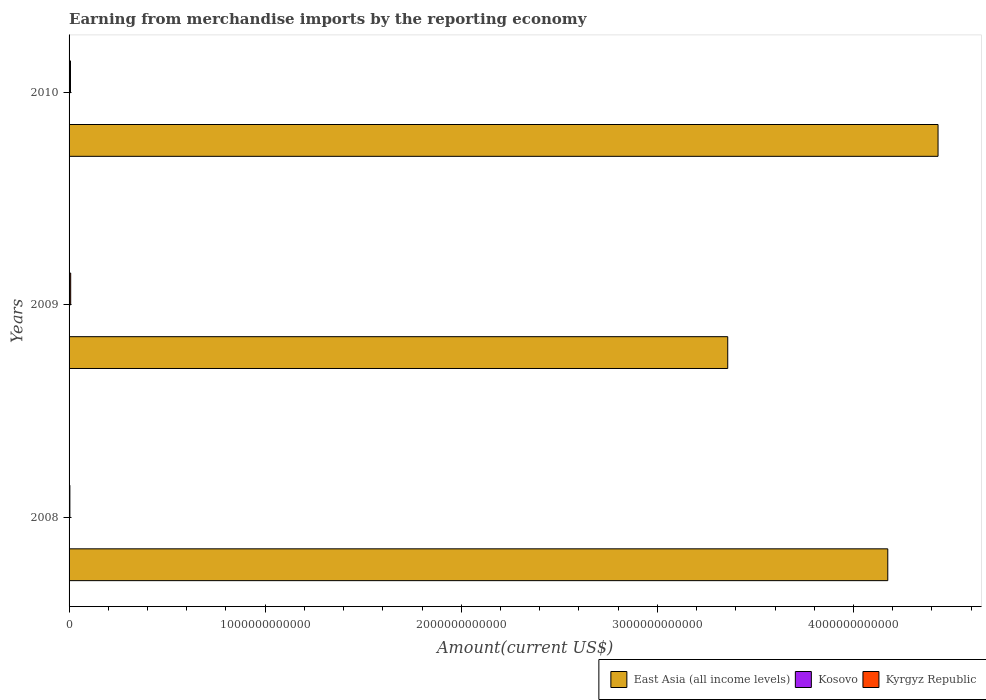How many different coloured bars are there?
Give a very brief answer. 3. How many groups of bars are there?
Ensure brevity in your answer.  3. Are the number of bars on each tick of the Y-axis equal?
Offer a very short reply. Yes. What is the label of the 1st group of bars from the top?
Your response must be concise. 2010. What is the amount earned from merchandise imports in East Asia (all income levels) in 2008?
Your answer should be compact. 4.17e+12. Across all years, what is the maximum amount earned from merchandise imports in East Asia (all income levels)?
Provide a short and direct response. 4.43e+12. Across all years, what is the minimum amount earned from merchandise imports in Kyrgyz Republic?
Offer a terse response. 4.07e+09. In which year was the amount earned from merchandise imports in Kosovo maximum?
Your answer should be very brief. 2009. In which year was the amount earned from merchandise imports in Kyrgyz Republic minimum?
Ensure brevity in your answer.  2008. What is the total amount earned from merchandise imports in Kyrgyz Republic in the graph?
Provide a short and direct response. 1.95e+1. What is the difference between the amount earned from merchandise imports in East Asia (all income levels) in 2009 and that in 2010?
Your response must be concise. -1.07e+12. What is the difference between the amount earned from merchandise imports in Kosovo in 2010 and the amount earned from merchandise imports in East Asia (all income levels) in 2008?
Offer a terse response. -4.17e+12. What is the average amount earned from merchandise imports in Kyrgyz Republic per year?
Make the answer very short. 6.51e+09. In the year 2010, what is the difference between the amount earned from merchandise imports in East Asia (all income levels) and amount earned from merchandise imports in Kyrgyz Republic?
Keep it short and to the point. 4.42e+12. In how many years, is the amount earned from merchandise imports in Kosovo greater than 3400000000000 US$?
Make the answer very short. 0. What is the ratio of the amount earned from merchandise imports in Kosovo in 2009 to that in 2010?
Give a very brief answer. 1.03. Is the amount earned from merchandise imports in Kyrgyz Republic in 2008 less than that in 2010?
Ensure brevity in your answer.  Yes. Is the difference between the amount earned from merchandise imports in East Asia (all income levels) in 2008 and 2009 greater than the difference between the amount earned from merchandise imports in Kyrgyz Republic in 2008 and 2009?
Give a very brief answer. Yes. What is the difference between the highest and the second highest amount earned from merchandise imports in East Asia (all income levels)?
Your response must be concise. 2.56e+11. What is the difference between the highest and the lowest amount earned from merchandise imports in Kyrgyz Republic?
Your response must be concise. 4.15e+09. What does the 2nd bar from the top in 2008 represents?
Your answer should be compact. Kosovo. What does the 1st bar from the bottom in 2010 represents?
Make the answer very short. East Asia (all income levels). Is it the case that in every year, the sum of the amount earned from merchandise imports in East Asia (all income levels) and amount earned from merchandise imports in Kosovo is greater than the amount earned from merchandise imports in Kyrgyz Republic?
Your response must be concise. Yes. Are all the bars in the graph horizontal?
Your answer should be compact. Yes. How many years are there in the graph?
Keep it short and to the point. 3. What is the difference between two consecutive major ticks on the X-axis?
Ensure brevity in your answer.  1.00e+12. Are the values on the major ticks of X-axis written in scientific E-notation?
Provide a succinct answer. No. Does the graph contain any zero values?
Provide a succinct answer. No. Where does the legend appear in the graph?
Your answer should be very brief. Bottom right. How many legend labels are there?
Offer a very short reply. 3. How are the legend labels stacked?
Provide a succinct answer. Horizontal. What is the title of the graph?
Offer a terse response. Earning from merchandise imports by the reporting economy. What is the label or title of the X-axis?
Provide a short and direct response. Amount(current US$). What is the Amount(current US$) in East Asia (all income levels) in 2008?
Ensure brevity in your answer.  4.17e+12. What is the Amount(current US$) in Kosovo in 2008?
Give a very brief answer. 1.27e+09. What is the Amount(current US$) in Kyrgyz Republic in 2008?
Keep it short and to the point. 4.07e+09. What is the Amount(current US$) in East Asia (all income levels) in 2009?
Your response must be concise. 3.36e+12. What is the Amount(current US$) of Kosovo in 2009?
Keep it short and to the point. 1.36e+09. What is the Amount(current US$) in Kyrgyz Republic in 2009?
Offer a terse response. 8.22e+09. What is the Amount(current US$) in East Asia (all income levels) in 2010?
Offer a terse response. 4.43e+12. What is the Amount(current US$) in Kosovo in 2010?
Ensure brevity in your answer.  1.32e+09. What is the Amount(current US$) of Kyrgyz Republic in 2010?
Offer a very short reply. 7.23e+09. Across all years, what is the maximum Amount(current US$) of East Asia (all income levels)?
Keep it short and to the point. 4.43e+12. Across all years, what is the maximum Amount(current US$) of Kosovo?
Your answer should be very brief. 1.36e+09. Across all years, what is the maximum Amount(current US$) of Kyrgyz Republic?
Provide a short and direct response. 8.22e+09. Across all years, what is the minimum Amount(current US$) in East Asia (all income levels)?
Your response must be concise. 3.36e+12. Across all years, what is the minimum Amount(current US$) in Kosovo?
Ensure brevity in your answer.  1.27e+09. Across all years, what is the minimum Amount(current US$) of Kyrgyz Republic?
Your response must be concise. 4.07e+09. What is the total Amount(current US$) in East Asia (all income levels) in the graph?
Offer a terse response. 1.20e+13. What is the total Amount(current US$) in Kosovo in the graph?
Your response must be concise. 3.95e+09. What is the total Amount(current US$) of Kyrgyz Republic in the graph?
Your answer should be compact. 1.95e+1. What is the difference between the Amount(current US$) of East Asia (all income levels) in 2008 and that in 2009?
Offer a very short reply. 8.16e+11. What is the difference between the Amount(current US$) in Kosovo in 2008 and that in 2009?
Your answer should be very brief. -9.32e+07. What is the difference between the Amount(current US$) of Kyrgyz Republic in 2008 and that in 2009?
Your response must be concise. -4.15e+09. What is the difference between the Amount(current US$) of East Asia (all income levels) in 2008 and that in 2010?
Ensure brevity in your answer.  -2.56e+11. What is the difference between the Amount(current US$) in Kosovo in 2008 and that in 2010?
Your answer should be compact. -4.82e+07. What is the difference between the Amount(current US$) in Kyrgyz Republic in 2008 and that in 2010?
Provide a short and direct response. -3.16e+09. What is the difference between the Amount(current US$) of East Asia (all income levels) in 2009 and that in 2010?
Your answer should be very brief. -1.07e+12. What is the difference between the Amount(current US$) of Kosovo in 2009 and that in 2010?
Your response must be concise. 4.51e+07. What is the difference between the Amount(current US$) of Kyrgyz Republic in 2009 and that in 2010?
Make the answer very short. 9.90e+08. What is the difference between the Amount(current US$) in East Asia (all income levels) in 2008 and the Amount(current US$) in Kosovo in 2009?
Give a very brief answer. 4.17e+12. What is the difference between the Amount(current US$) in East Asia (all income levels) in 2008 and the Amount(current US$) in Kyrgyz Republic in 2009?
Give a very brief answer. 4.17e+12. What is the difference between the Amount(current US$) in Kosovo in 2008 and the Amount(current US$) in Kyrgyz Republic in 2009?
Ensure brevity in your answer.  -6.95e+09. What is the difference between the Amount(current US$) in East Asia (all income levels) in 2008 and the Amount(current US$) in Kosovo in 2010?
Your response must be concise. 4.17e+12. What is the difference between the Amount(current US$) in East Asia (all income levels) in 2008 and the Amount(current US$) in Kyrgyz Republic in 2010?
Provide a short and direct response. 4.17e+12. What is the difference between the Amount(current US$) in Kosovo in 2008 and the Amount(current US$) in Kyrgyz Republic in 2010?
Provide a succinct answer. -5.96e+09. What is the difference between the Amount(current US$) of East Asia (all income levels) in 2009 and the Amount(current US$) of Kosovo in 2010?
Your answer should be very brief. 3.36e+12. What is the difference between the Amount(current US$) of East Asia (all income levels) in 2009 and the Amount(current US$) of Kyrgyz Republic in 2010?
Your response must be concise. 3.35e+12. What is the difference between the Amount(current US$) of Kosovo in 2009 and the Amount(current US$) of Kyrgyz Republic in 2010?
Ensure brevity in your answer.  -5.87e+09. What is the average Amount(current US$) of East Asia (all income levels) per year?
Your answer should be very brief. 3.99e+12. What is the average Amount(current US$) in Kosovo per year?
Make the answer very short. 1.32e+09. What is the average Amount(current US$) in Kyrgyz Republic per year?
Provide a succinct answer. 6.51e+09. In the year 2008, what is the difference between the Amount(current US$) in East Asia (all income levels) and Amount(current US$) in Kosovo?
Your response must be concise. 4.17e+12. In the year 2008, what is the difference between the Amount(current US$) in East Asia (all income levels) and Amount(current US$) in Kyrgyz Republic?
Keep it short and to the point. 4.17e+12. In the year 2008, what is the difference between the Amount(current US$) in Kosovo and Amount(current US$) in Kyrgyz Republic?
Ensure brevity in your answer.  -2.80e+09. In the year 2009, what is the difference between the Amount(current US$) in East Asia (all income levels) and Amount(current US$) in Kosovo?
Keep it short and to the point. 3.36e+12. In the year 2009, what is the difference between the Amount(current US$) in East Asia (all income levels) and Amount(current US$) in Kyrgyz Republic?
Your response must be concise. 3.35e+12. In the year 2009, what is the difference between the Amount(current US$) of Kosovo and Amount(current US$) of Kyrgyz Republic?
Provide a succinct answer. -6.86e+09. In the year 2010, what is the difference between the Amount(current US$) of East Asia (all income levels) and Amount(current US$) of Kosovo?
Give a very brief answer. 4.43e+12. In the year 2010, what is the difference between the Amount(current US$) in East Asia (all income levels) and Amount(current US$) in Kyrgyz Republic?
Offer a terse response. 4.42e+12. In the year 2010, what is the difference between the Amount(current US$) of Kosovo and Amount(current US$) of Kyrgyz Republic?
Offer a very short reply. -5.91e+09. What is the ratio of the Amount(current US$) of East Asia (all income levels) in 2008 to that in 2009?
Provide a short and direct response. 1.24. What is the ratio of the Amount(current US$) of Kosovo in 2008 to that in 2009?
Make the answer very short. 0.93. What is the ratio of the Amount(current US$) of Kyrgyz Republic in 2008 to that in 2009?
Your answer should be compact. 0.5. What is the ratio of the Amount(current US$) of East Asia (all income levels) in 2008 to that in 2010?
Keep it short and to the point. 0.94. What is the ratio of the Amount(current US$) in Kosovo in 2008 to that in 2010?
Make the answer very short. 0.96. What is the ratio of the Amount(current US$) of Kyrgyz Republic in 2008 to that in 2010?
Your response must be concise. 0.56. What is the ratio of the Amount(current US$) of East Asia (all income levels) in 2009 to that in 2010?
Your response must be concise. 0.76. What is the ratio of the Amount(current US$) in Kosovo in 2009 to that in 2010?
Offer a very short reply. 1.03. What is the ratio of the Amount(current US$) in Kyrgyz Republic in 2009 to that in 2010?
Ensure brevity in your answer.  1.14. What is the difference between the highest and the second highest Amount(current US$) in East Asia (all income levels)?
Ensure brevity in your answer.  2.56e+11. What is the difference between the highest and the second highest Amount(current US$) in Kosovo?
Offer a very short reply. 4.51e+07. What is the difference between the highest and the second highest Amount(current US$) in Kyrgyz Republic?
Provide a succinct answer. 9.90e+08. What is the difference between the highest and the lowest Amount(current US$) in East Asia (all income levels)?
Offer a terse response. 1.07e+12. What is the difference between the highest and the lowest Amount(current US$) of Kosovo?
Provide a succinct answer. 9.32e+07. What is the difference between the highest and the lowest Amount(current US$) of Kyrgyz Republic?
Your answer should be very brief. 4.15e+09. 